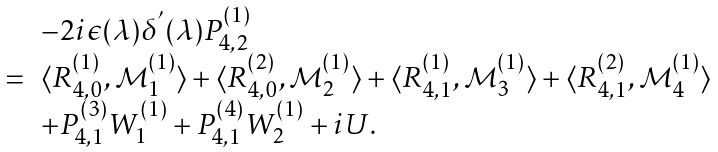<formula> <loc_0><loc_0><loc_500><loc_500>\begin{array} { l l l } & & - 2 i \epsilon ( \lambda ) \delta ^ { ^ { \prime } } ( \lambda ) P _ { 4 , 2 } ^ { ( 1 ) } \\ & = & \langle R _ { 4 , 0 } ^ { ( 1 ) } , \mathcal { M } _ { 1 } ^ { ( 1 ) } \rangle + \langle R _ { 4 , 0 } ^ { ( 2 ) } , \mathcal { M } _ { 2 } ^ { ( 1 ) } \rangle + \langle R _ { 4 , 1 } ^ { ( 1 ) } , \mathcal { M } _ { 3 } ^ { ( 1 ) } \rangle + \langle R _ { 4 , 1 } ^ { ( 2 ) } , \mathcal { M } _ { 4 } ^ { ( 1 ) } \rangle \\ & & + P _ { 4 , 1 } ^ { ( 3 ) } W _ { 1 } ^ { ( 1 ) } + P _ { 4 , 1 } ^ { ( 4 ) } W _ { 2 } ^ { ( 1 ) } + i U . \end{array}</formula> 